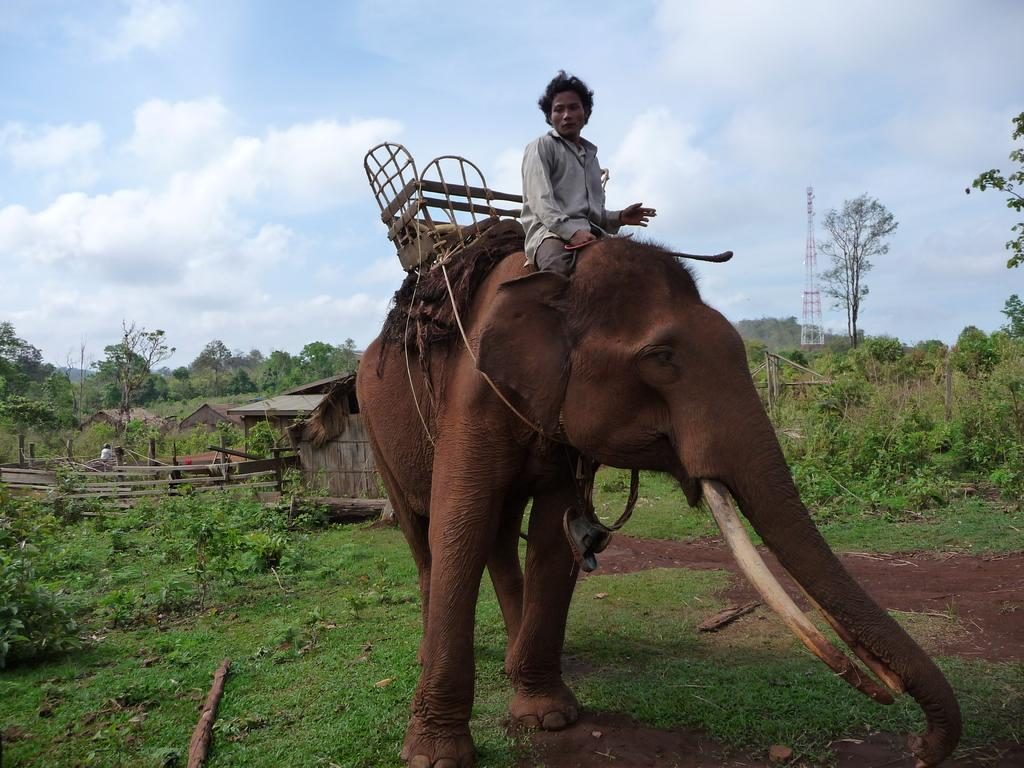What is the main subject of the image? There is a person in the image. What is the person doing in the image? The person is sitting on an elephant. What can be seen in the background of the image? There are trees and the sky visible in the background of the image. What type of wristwatch is the zebra wearing in the image? There is no zebra present in the image, and therefore no wristwatch to observe. 